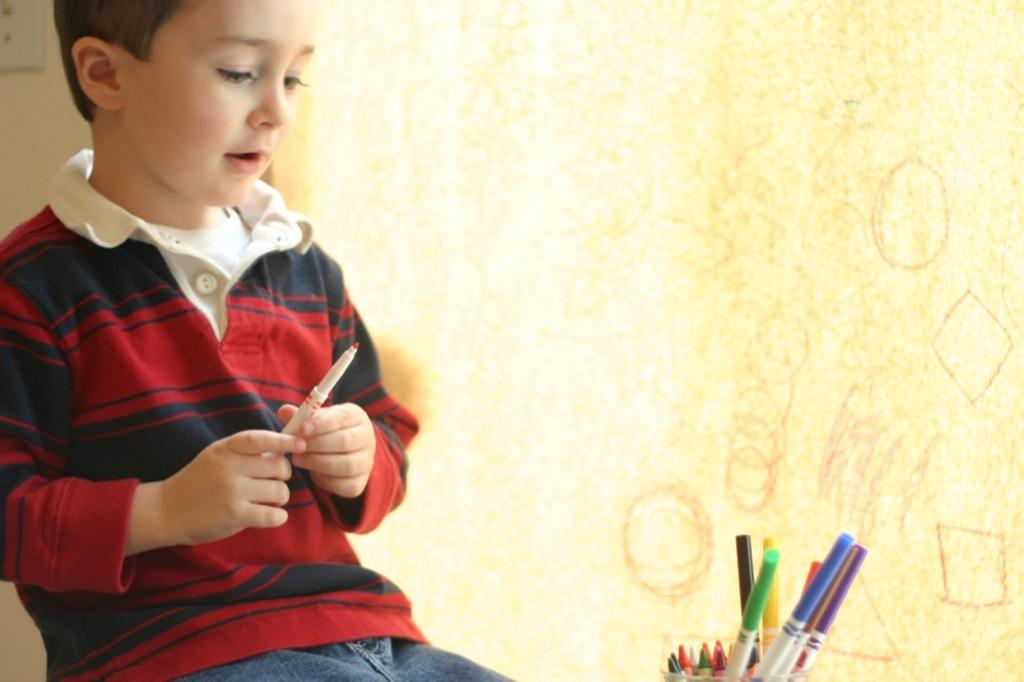What objects are located in the front of the image? There are pens in the front of the image. Who is present in the image? There is a boy in the image. What is the boy holding in his hand? The boy is holding a pen in his hand. What can be seen in the background of the image? There is a wall in the background of the image. What type of stove can be seen in the image? There is no stove present in the image. How many pets are visible in the image? There are no pets visible in the image. 